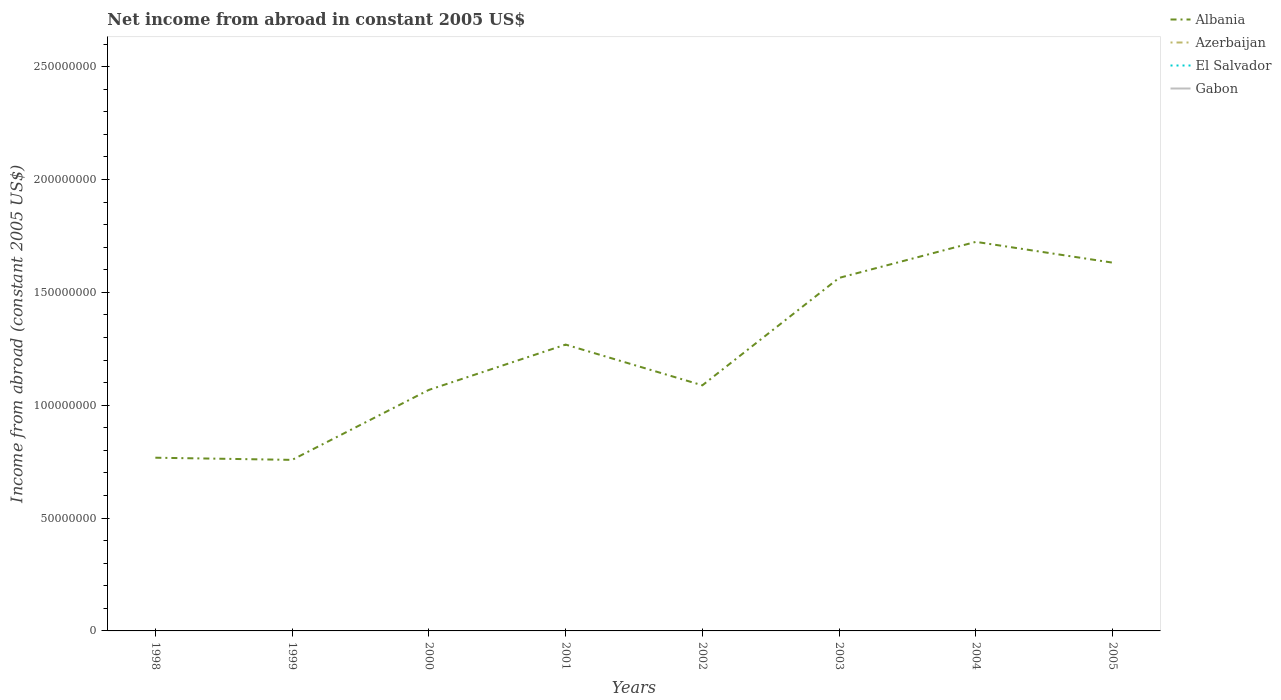Does the line corresponding to Albania intersect with the line corresponding to El Salvador?
Keep it short and to the point. No. Is the number of lines equal to the number of legend labels?
Provide a succinct answer. No. What is the difference between the highest and the second highest net income from abroad in Albania?
Make the answer very short. 9.66e+07. How many lines are there?
Offer a very short reply. 1. What is the difference between two consecutive major ticks on the Y-axis?
Your answer should be very brief. 5.00e+07. Are the values on the major ticks of Y-axis written in scientific E-notation?
Provide a short and direct response. No. Does the graph contain grids?
Provide a short and direct response. No. How are the legend labels stacked?
Give a very brief answer. Vertical. What is the title of the graph?
Your answer should be compact. Net income from abroad in constant 2005 US$. Does "Vanuatu" appear as one of the legend labels in the graph?
Your response must be concise. No. What is the label or title of the X-axis?
Offer a terse response. Years. What is the label or title of the Y-axis?
Ensure brevity in your answer.  Income from abroad (constant 2005 US$). What is the Income from abroad (constant 2005 US$) in Albania in 1998?
Your response must be concise. 7.67e+07. What is the Income from abroad (constant 2005 US$) in Albania in 1999?
Ensure brevity in your answer.  7.58e+07. What is the Income from abroad (constant 2005 US$) in Azerbaijan in 1999?
Ensure brevity in your answer.  0. What is the Income from abroad (constant 2005 US$) of Albania in 2000?
Your answer should be compact. 1.07e+08. What is the Income from abroad (constant 2005 US$) of Azerbaijan in 2000?
Ensure brevity in your answer.  0. What is the Income from abroad (constant 2005 US$) in Albania in 2001?
Give a very brief answer. 1.27e+08. What is the Income from abroad (constant 2005 US$) of El Salvador in 2001?
Your answer should be compact. 0. What is the Income from abroad (constant 2005 US$) in Albania in 2002?
Offer a very short reply. 1.09e+08. What is the Income from abroad (constant 2005 US$) of Azerbaijan in 2002?
Your response must be concise. 0. What is the Income from abroad (constant 2005 US$) in Albania in 2003?
Your answer should be very brief. 1.56e+08. What is the Income from abroad (constant 2005 US$) of Gabon in 2003?
Ensure brevity in your answer.  0. What is the Income from abroad (constant 2005 US$) of Albania in 2004?
Provide a short and direct response. 1.72e+08. What is the Income from abroad (constant 2005 US$) of Azerbaijan in 2004?
Your response must be concise. 0. What is the Income from abroad (constant 2005 US$) of Albania in 2005?
Give a very brief answer. 1.63e+08. Across all years, what is the maximum Income from abroad (constant 2005 US$) in Albania?
Ensure brevity in your answer.  1.72e+08. Across all years, what is the minimum Income from abroad (constant 2005 US$) of Albania?
Offer a terse response. 7.58e+07. What is the total Income from abroad (constant 2005 US$) in Albania in the graph?
Your answer should be very brief. 9.87e+08. What is the total Income from abroad (constant 2005 US$) in Azerbaijan in the graph?
Your response must be concise. 0. What is the total Income from abroad (constant 2005 US$) in El Salvador in the graph?
Give a very brief answer. 0. What is the difference between the Income from abroad (constant 2005 US$) in Albania in 1998 and that in 1999?
Keep it short and to the point. 9.58e+05. What is the difference between the Income from abroad (constant 2005 US$) of Albania in 1998 and that in 2000?
Your answer should be very brief. -3.00e+07. What is the difference between the Income from abroad (constant 2005 US$) in Albania in 1998 and that in 2001?
Provide a short and direct response. -5.01e+07. What is the difference between the Income from abroad (constant 2005 US$) of Albania in 1998 and that in 2002?
Your answer should be very brief. -3.21e+07. What is the difference between the Income from abroad (constant 2005 US$) of Albania in 1998 and that in 2003?
Ensure brevity in your answer.  -7.97e+07. What is the difference between the Income from abroad (constant 2005 US$) of Albania in 1998 and that in 2004?
Your answer should be very brief. -9.56e+07. What is the difference between the Income from abroad (constant 2005 US$) in Albania in 1998 and that in 2005?
Your response must be concise. -8.64e+07. What is the difference between the Income from abroad (constant 2005 US$) in Albania in 1999 and that in 2000?
Offer a terse response. -3.10e+07. What is the difference between the Income from abroad (constant 2005 US$) of Albania in 1999 and that in 2001?
Provide a short and direct response. -5.11e+07. What is the difference between the Income from abroad (constant 2005 US$) in Albania in 1999 and that in 2002?
Your response must be concise. -3.30e+07. What is the difference between the Income from abroad (constant 2005 US$) of Albania in 1999 and that in 2003?
Your answer should be compact. -8.06e+07. What is the difference between the Income from abroad (constant 2005 US$) in Albania in 1999 and that in 2004?
Offer a very short reply. -9.66e+07. What is the difference between the Income from abroad (constant 2005 US$) of Albania in 1999 and that in 2005?
Make the answer very short. -8.74e+07. What is the difference between the Income from abroad (constant 2005 US$) of Albania in 2000 and that in 2001?
Offer a very short reply. -2.01e+07. What is the difference between the Income from abroad (constant 2005 US$) in Albania in 2000 and that in 2002?
Your answer should be very brief. -2.03e+06. What is the difference between the Income from abroad (constant 2005 US$) of Albania in 2000 and that in 2003?
Your answer should be compact. -4.96e+07. What is the difference between the Income from abroad (constant 2005 US$) in Albania in 2000 and that in 2004?
Ensure brevity in your answer.  -6.56e+07. What is the difference between the Income from abroad (constant 2005 US$) of Albania in 2000 and that in 2005?
Your answer should be very brief. -5.64e+07. What is the difference between the Income from abroad (constant 2005 US$) in Albania in 2001 and that in 2002?
Provide a succinct answer. 1.80e+07. What is the difference between the Income from abroad (constant 2005 US$) in Albania in 2001 and that in 2003?
Ensure brevity in your answer.  -2.96e+07. What is the difference between the Income from abroad (constant 2005 US$) of Albania in 2001 and that in 2004?
Provide a succinct answer. -4.55e+07. What is the difference between the Income from abroad (constant 2005 US$) of Albania in 2001 and that in 2005?
Provide a succinct answer. -3.63e+07. What is the difference between the Income from abroad (constant 2005 US$) in Albania in 2002 and that in 2003?
Offer a terse response. -4.76e+07. What is the difference between the Income from abroad (constant 2005 US$) in Albania in 2002 and that in 2004?
Make the answer very short. -6.36e+07. What is the difference between the Income from abroad (constant 2005 US$) of Albania in 2002 and that in 2005?
Your answer should be compact. -5.43e+07. What is the difference between the Income from abroad (constant 2005 US$) in Albania in 2003 and that in 2004?
Offer a very short reply. -1.60e+07. What is the difference between the Income from abroad (constant 2005 US$) of Albania in 2003 and that in 2005?
Keep it short and to the point. -6.75e+06. What is the difference between the Income from abroad (constant 2005 US$) of Albania in 2004 and that in 2005?
Your response must be concise. 9.21e+06. What is the average Income from abroad (constant 2005 US$) in Albania per year?
Make the answer very short. 1.23e+08. What is the average Income from abroad (constant 2005 US$) of El Salvador per year?
Provide a short and direct response. 0. What is the ratio of the Income from abroad (constant 2005 US$) of Albania in 1998 to that in 1999?
Keep it short and to the point. 1.01. What is the ratio of the Income from abroad (constant 2005 US$) of Albania in 1998 to that in 2000?
Ensure brevity in your answer.  0.72. What is the ratio of the Income from abroad (constant 2005 US$) of Albania in 1998 to that in 2001?
Ensure brevity in your answer.  0.6. What is the ratio of the Income from abroad (constant 2005 US$) of Albania in 1998 to that in 2002?
Provide a succinct answer. 0.71. What is the ratio of the Income from abroad (constant 2005 US$) of Albania in 1998 to that in 2003?
Offer a very short reply. 0.49. What is the ratio of the Income from abroad (constant 2005 US$) in Albania in 1998 to that in 2004?
Your answer should be compact. 0.45. What is the ratio of the Income from abroad (constant 2005 US$) of Albania in 1998 to that in 2005?
Your answer should be compact. 0.47. What is the ratio of the Income from abroad (constant 2005 US$) of Albania in 1999 to that in 2000?
Offer a terse response. 0.71. What is the ratio of the Income from abroad (constant 2005 US$) in Albania in 1999 to that in 2001?
Give a very brief answer. 0.6. What is the ratio of the Income from abroad (constant 2005 US$) of Albania in 1999 to that in 2002?
Provide a short and direct response. 0.7. What is the ratio of the Income from abroad (constant 2005 US$) of Albania in 1999 to that in 2003?
Your answer should be very brief. 0.48. What is the ratio of the Income from abroad (constant 2005 US$) of Albania in 1999 to that in 2004?
Offer a very short reply. 0.44. What is the ratio of the Income from abroad (constant 2005 US$) of Albania in 1999 to that in 2005?
Your answer should be very brief. 0.46. What is the ratio of the Income from abroad (constant 2005 US$) in Albania in 2000 to that in 2001?
Provide a succinct answer. 0.84. What is the ratio of the Income from abroad (constant 2005 US$) in Albania in 2000 to that in 2002?
Your response must be concise. 0.98. What is the ratio of the Income from abroad (constant 2005 US$) in Albania in 2000 to that in 2003?
Ensure brevity in your answer.  0.68. What is the ratio of the Income from abroad (constant 2005 US$) in Albania in 2000 to that in 2004?
Give a very brief answer. 0.62. What is the ratio of the Income from abroad (constant 2005 US$) in Albania in 2000 to that in 2005?
Your answer should be very brief. 0.65. What is the ratio of the Income from abroad (constant 2005 US$) of Albania in 2001 to that in 2002?
Provide a short and direct response. 1.17. What is the ratio of the Income from abroad (constant 2005 US$) in Albania in 2001 to that in 2003?
Offer a terse response. 0.81. What is the ratio of the Income from abroad (constant 2005 US$) of Albania in 2001 to that in 2004?
Offer a very short reply. 0.74. What is the ratio of the Income from abroad (constant 2005 US$) in Albania in 2001 to that in 2005?
Your answer should be compact. 0.78. What is the ratio of the Income from abroad (constant 2005 US$) of Albania in 2002 to that in 2003?
Your answer should be compact. 0.7. What is the ratio of the Income from abroad (constant 2005 US$) in Albania in 2002 to that in 2004?
Provide a succinct answer. 0.63. What is the ratio of the Income from abroad (constant 2005 US$) of Albania in 2002 to that in 2005?
Your response must be concise. 0.67. What is the ratio of the Income from abroad (constant 2005 US$) of Albania in 2003 to that in 2004?
Your answer should be very brief. 0.91. What is the ratio of the Income from abroad (constant 2005 US$) in Albania in 2003 to that in 2005?
Your response must be concise. 0.96. What is the ratio of the Income from abroad (constant 2005 US$) of Albania in 2004 to that in 2005?
Your response must be concise. 1.06. What is the difference between the highest and the second highest Income from abroad (constant 2005 US$) in Albania?
Offer a terse response. 9.21e+06. What is the difference between the highest and the lowest Income from abroad (constant 2005 US$) in Albania?
Your answer should be compact. 9.66e+07. 